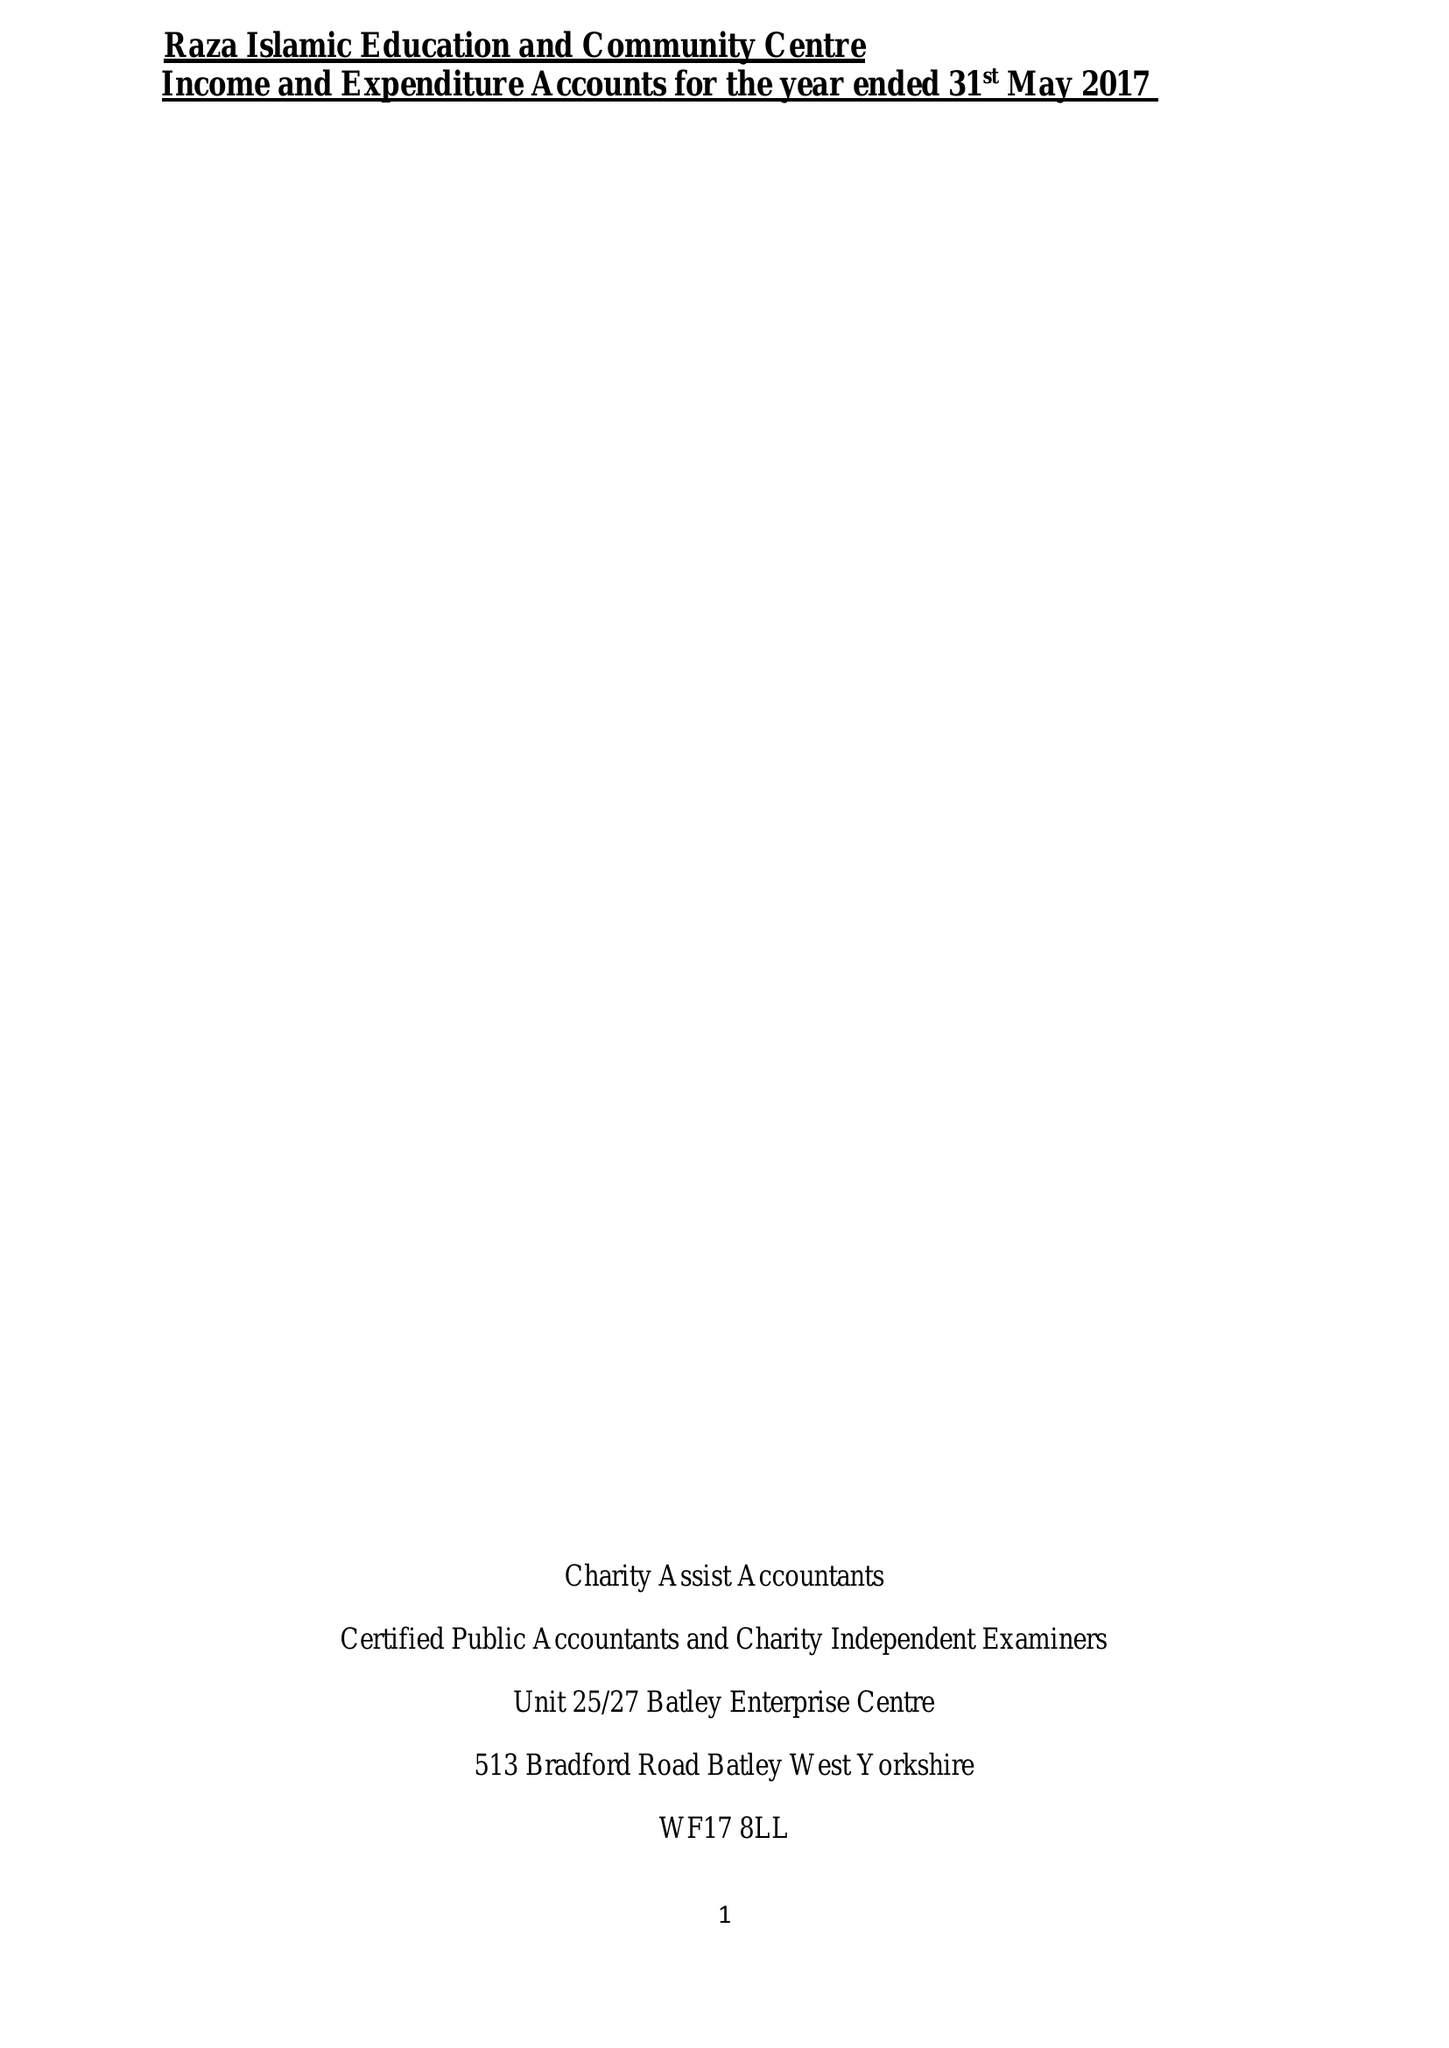What is the value for the report_date?
Answer the question using a single word or phrase. 2017-05-31 